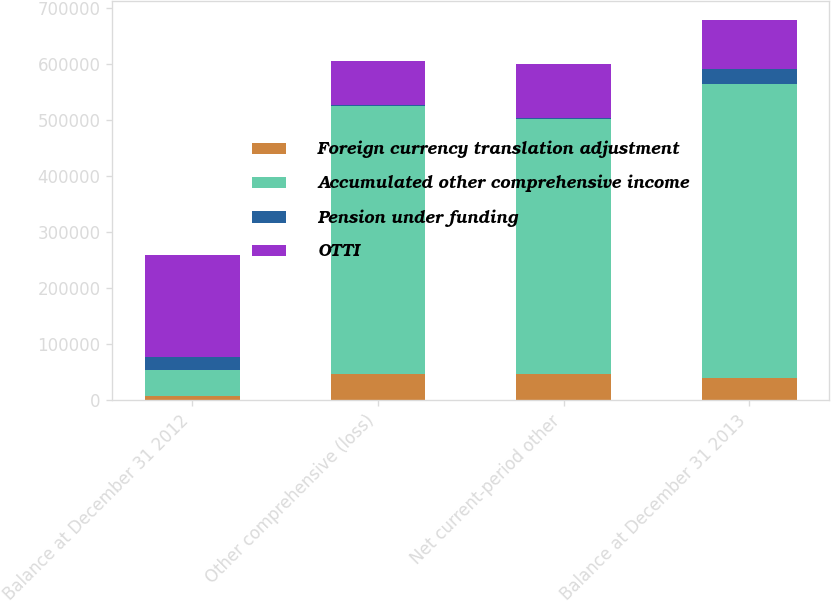Convert chart to OTSL. <chart><loc_0><loc_0><loc_500><loc_500><stacked_bar_chart><ecel><fcel>Balance at December 31 2012<fcel>Other comprehensive (loss)<fcel>Net current-period other<fcel>Balance at December 31 2013<nl><fcel>Foreign currency translation adjustment<fcel>6882<fcel>45649<fcel>45649<fcel>38767<nl><fcel>Accumulated other comprehensive income<fcel>45649<fcel>478853<fcel>455808<fcel>526071<nl><fcel>Pension under funding<fcel>23861<fcel>2237<fcel>2566<fcel>26427<nl><fcel>OTTI<fcel>182219<fcel>77938<fcel>95318<fcel>86901<nl></chart> 